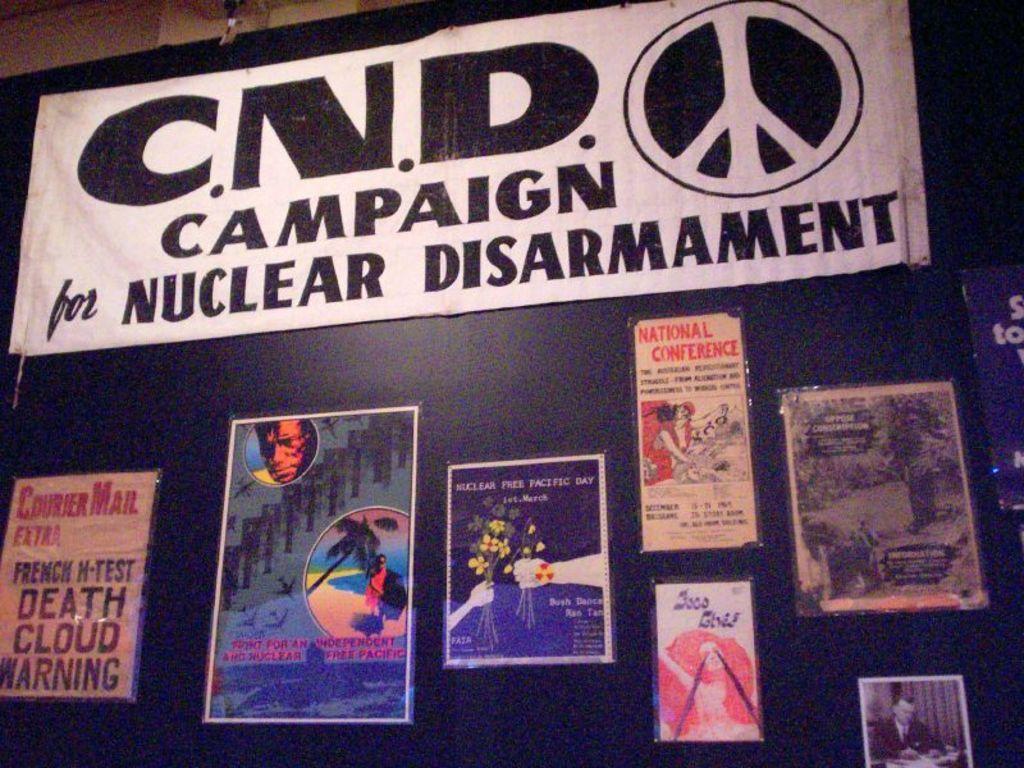Can you describe this image briefly? In this picture we can see some posters and a notice pasted on a blackboard. 